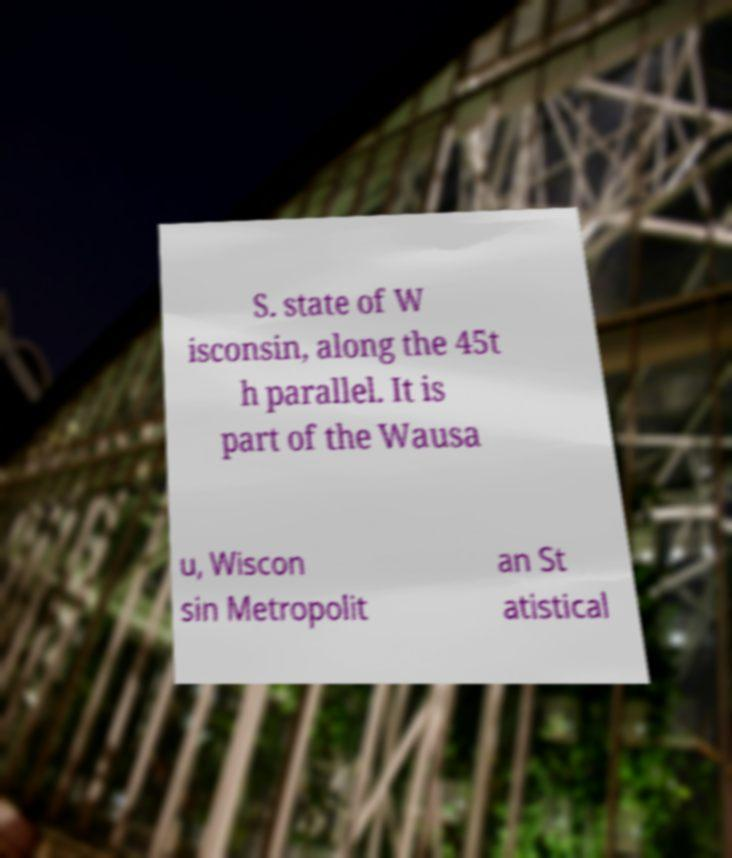Could you extract and type out the text from this image? S. state of W isconsin, along the 45t h parallel. It is part of the Wausa u, Wiscon sin Metropolit an St atistical 